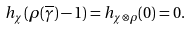<formula> <loc_0><loc_0><loc_500><loc_500>h _ { \chi } ( \rho ( \overline { \gamma } ) - 1 ) = h _ { \chi \otimes \rho } ( 0 ) = 0 .</formula> 